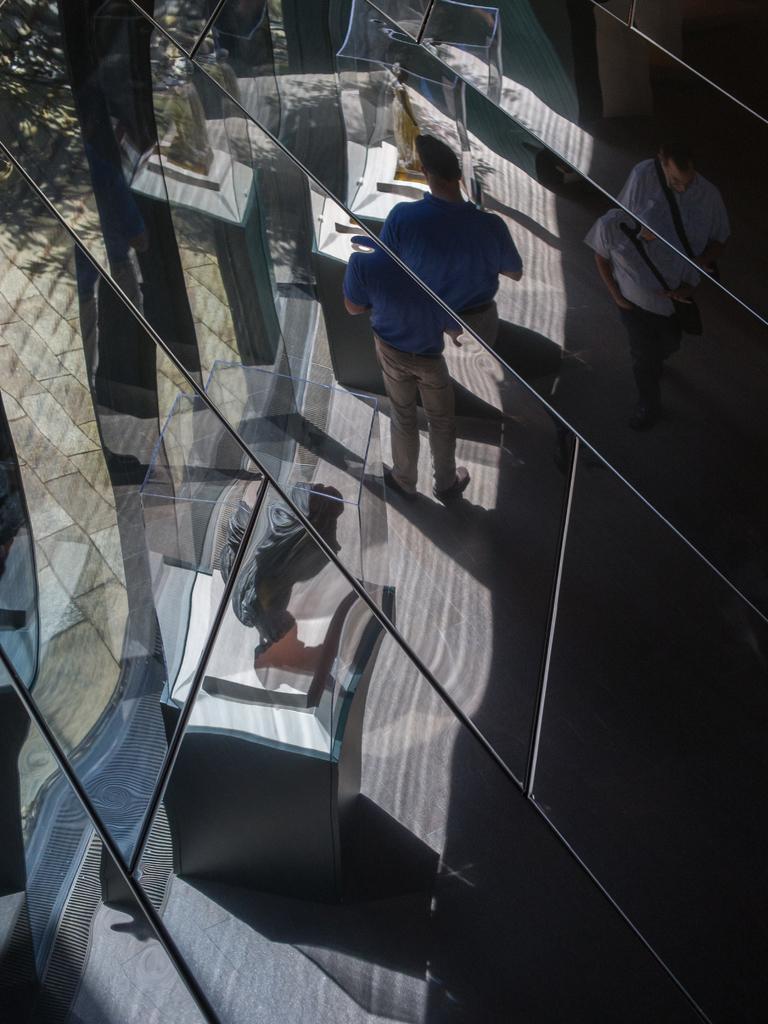How would you summarize this image in a sentence or two? In this image we can see a wall with pieces of glass. Through that we can see persons, statue on a pedestal and some other things. 